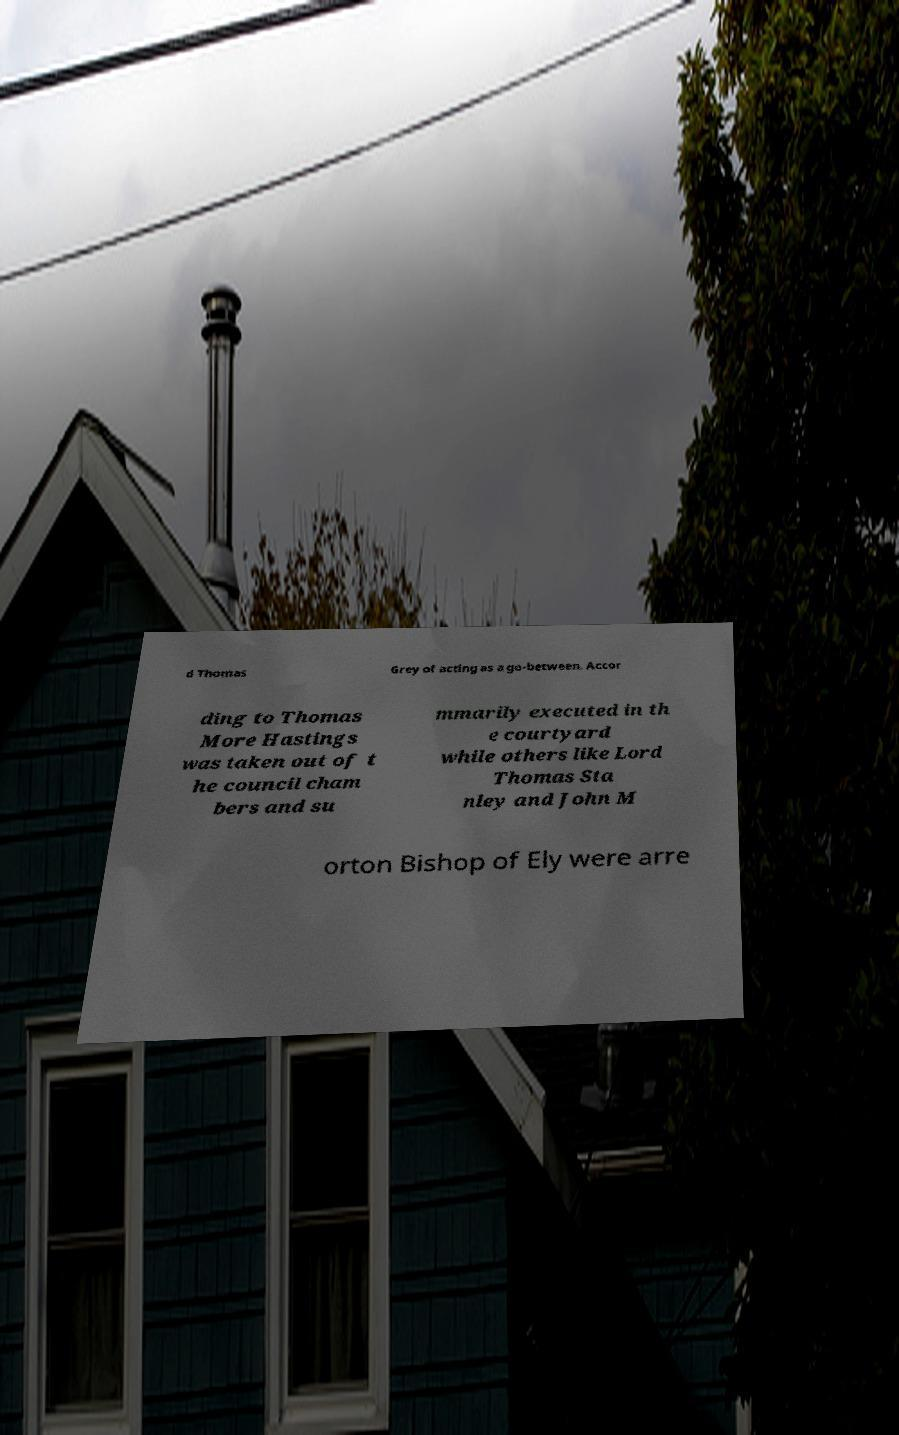What messages or text are displayed in this image? I need them in a readable, typed format. d Thomas Grey of acting as a go-between. Accor ding to Thomas More Hastings was taken out of t he council cham bers and su mmarily executed in th e courtyard while others like Lord Thomas Sta nley and John M orton Bishop of Ely were arre 